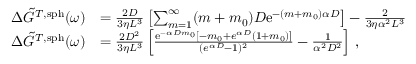Convert formula to latex. <formula><loc_0><loc_0><loc_500><loc_500>\begin{array} { r l } { \Delta \tilde { G } ^ { T , s p h } ( \omega ) } & { = \frac { 2 D } { 3 \eta L ^ { 3 } } \left [ \sum _ { m = 1 } ^ { \infty } ( m + m _ { 0 } ) D e ^ { - ( m + m _ { 0 } ) \alpha D } \right ] - \frac { 2 } { 3 \eta \alpha ^ { 2 } L ^ { 3 } } } \\ { \Delta \tilde { G } ^ { T , s p h } ( \omega ) } & { = \frac { 2 D ^ { 2 } } { 3 \eta L ^ { 3 } } \left [ \frac { e ^ { - \alpha D m _ { 0 } } [ - m _ { 0 } + e ^ { \alpha D } ( 1 + m _ { 0 } ) ] } { ( { e } ^ { \alpha D } - 1 ) ^ { 2 } } - \frac { 1 } { \alpha ^ { 2 } D ^ { 2 } } \right ] \, , } \end{array}</formula> 